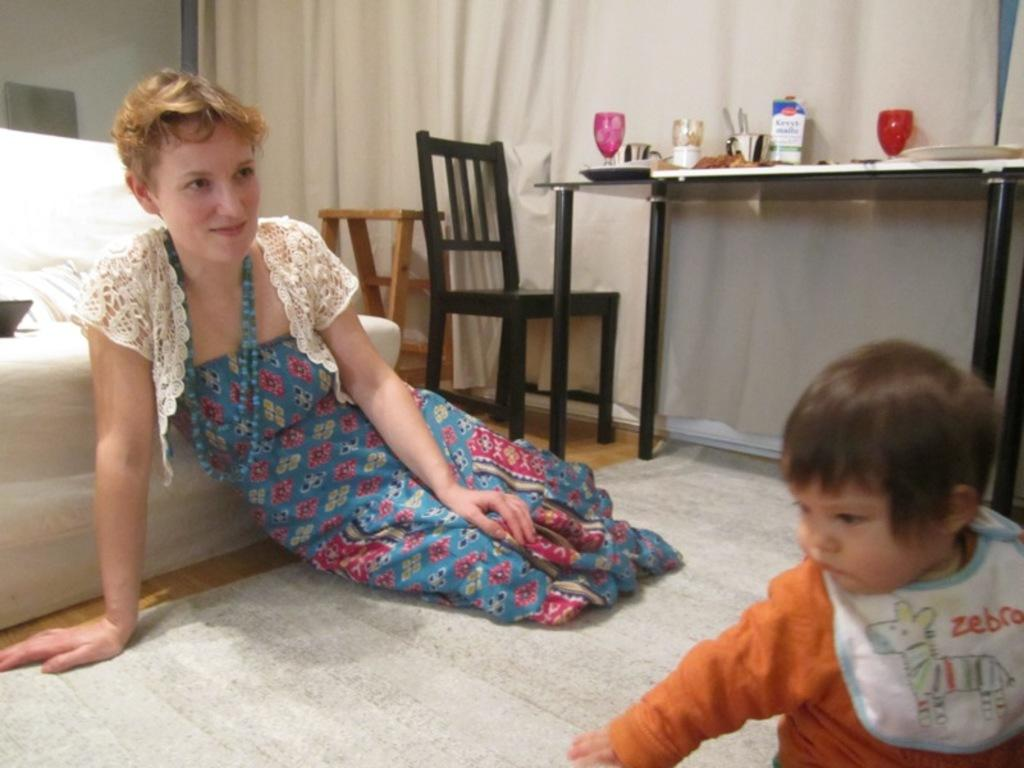Provide a one-sentence caption for the provided image. the word zebra is on the bib of the baby. 